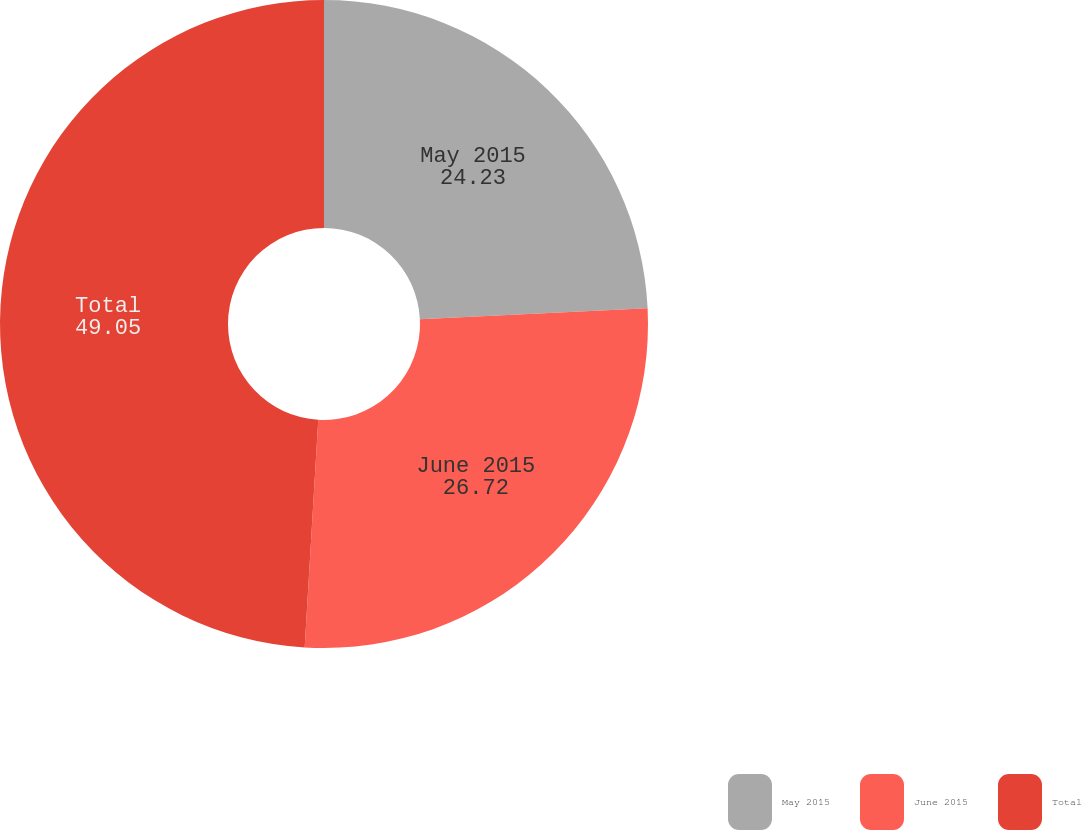Convert chart. <chart><loc_0><loc_0><loc_500><loc_500><pie_chart><fcel>May 2015<fcel>June 2015<fcel>Total<nl><fcel>24.23%<fcel>26.72%<fcel>49.05%<nl></chart> 